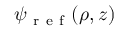Convert formula to latex. <formula><loc_0><loc_0><loc_500><loc_500>\psi _ { r e f } ( \rho , z )</formula> 